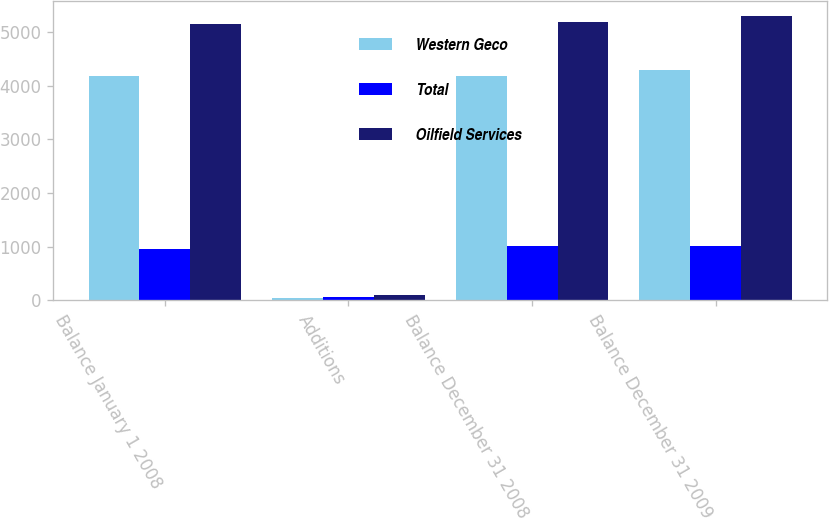Convert chart to OTSL. <chart><loc_0><loc_0><loc_500><loc_500><stacked_bar_chart><ecel><fcel>Balance January 1 2008<fcel>Additions<fcel>Balance December 31 2008<fcel>Balance December 31 2009<nl><fcel>Western Geco<fcel>4185<fcel>49<fcel>4174<fcel>4290<nl><fcel>Total<fcel>957<fcel>58<fcel>1015<fcel>1015<nl><fcel>Oilfield Services<fcel>5142<fcel>107<fcel>5189<fcel>5305<nl></chart> 